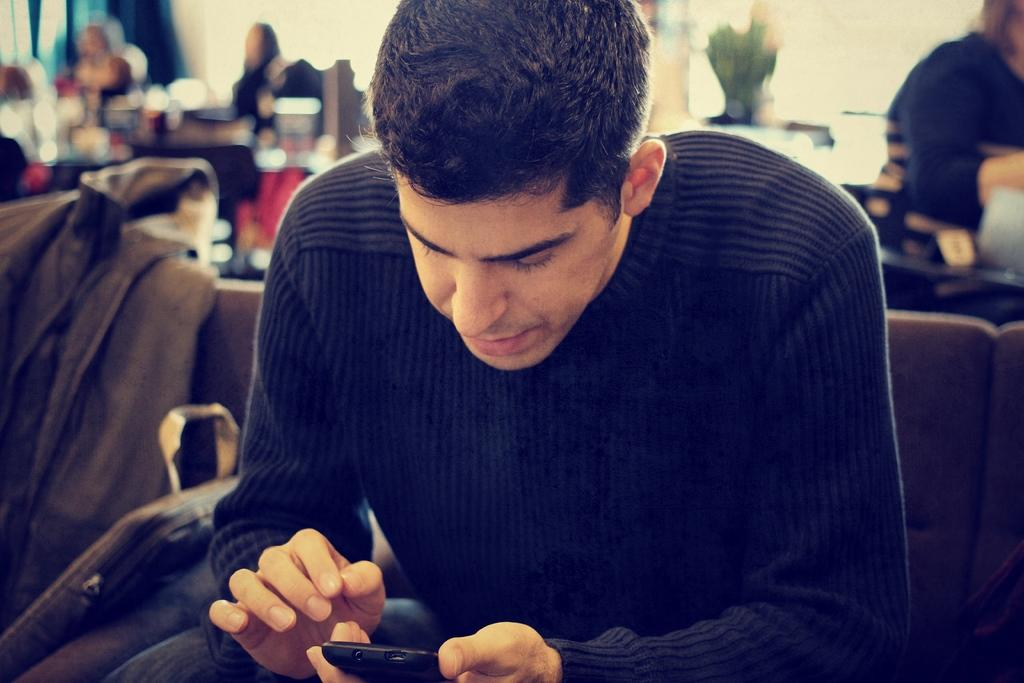What are the people in the image doing? The persons in the image are sitting on chairs. What items can be seen near the people in the image? Backpacks are visible in the image. What type of clothing is present in the image? Jackets are present in the image. What type of vegetation is present in the image? Plants are present in the image. Can you see a rabbit in the image? No, there is no rabbit present in the image. 